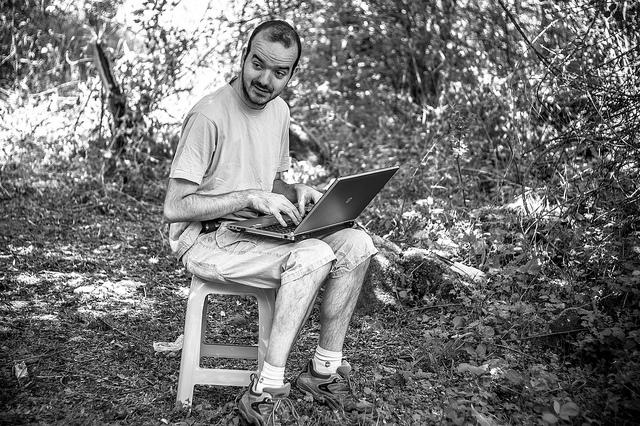Is the picture colored?
Quick response, please. No. Is the man in his natural habitat?
Write a very short answer. No. What is the man sitting on?
Quick response, please. Stool. 